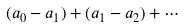<formula> <loc_0><loc_0><loc_500><loc_500>( a _ { 0 } - a _ { 1 } ) + ( a _ { 1 } - a _ { 2 } ) + \cdots</formula> 